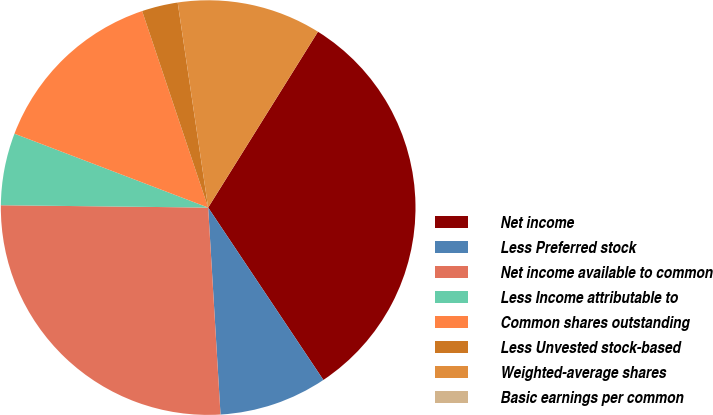Convert chart to OTSL. <chart><loc_0><loc_0><loc_500><loc_500><pie_chart><fcel>Net income<fcel>Less Preferred stock<fcel>Net income available to common<fcel>Less Income attributable to<fcel>Common shares outstanding<fcel>Less Unvested stock-based<fcel>Weighted-average shares<fcel>Basic earnings per common<nl><fcel>31.74%<fcel>8.43%<fcel>26.13%<fcel>5.62%<fcel>14.04%<fcel>2.81%<fcel>11.23%<fcel>0.0%<nl></chart> 